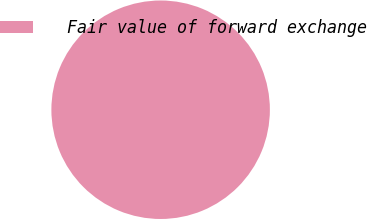<chart> <loc_0><loc_0><loc_500><loc_500><pie_chart><fcel>Fair value of forward exchange<nl><fcel>100.0%<nl></chart> 